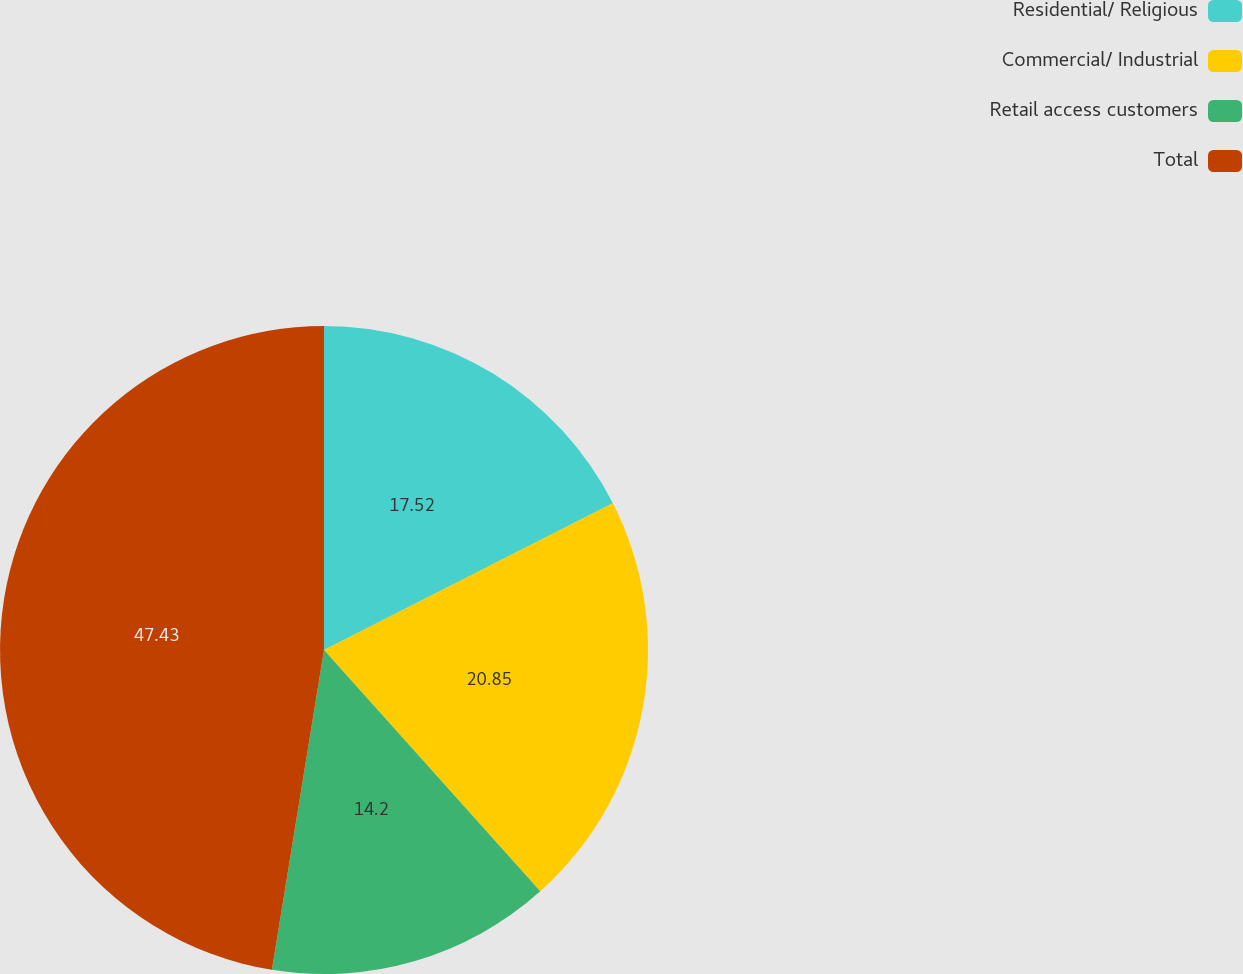Convert chart to OTSL. <chart><loc_0><loc_0><loc_500><loc_500><pie_chart><fcel>Residential/ Religious<fcel>Commercial/ Industrial<fcel>Retail access customers<fcel>Total<nl><fcel>17.52%<fcel>20.85%<fcel>14.2%<fcel>47.43%<nl></chart> 